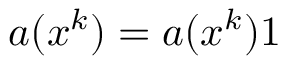Convert formula to latex. <formula><loc_0><loc_0><loc_500><loc_500>\boldsymbol a ( \boldsymbol x ^ { k } ) = a ( \boldsymbol x ^ { k } ) \boldsymbol 1</formula> 